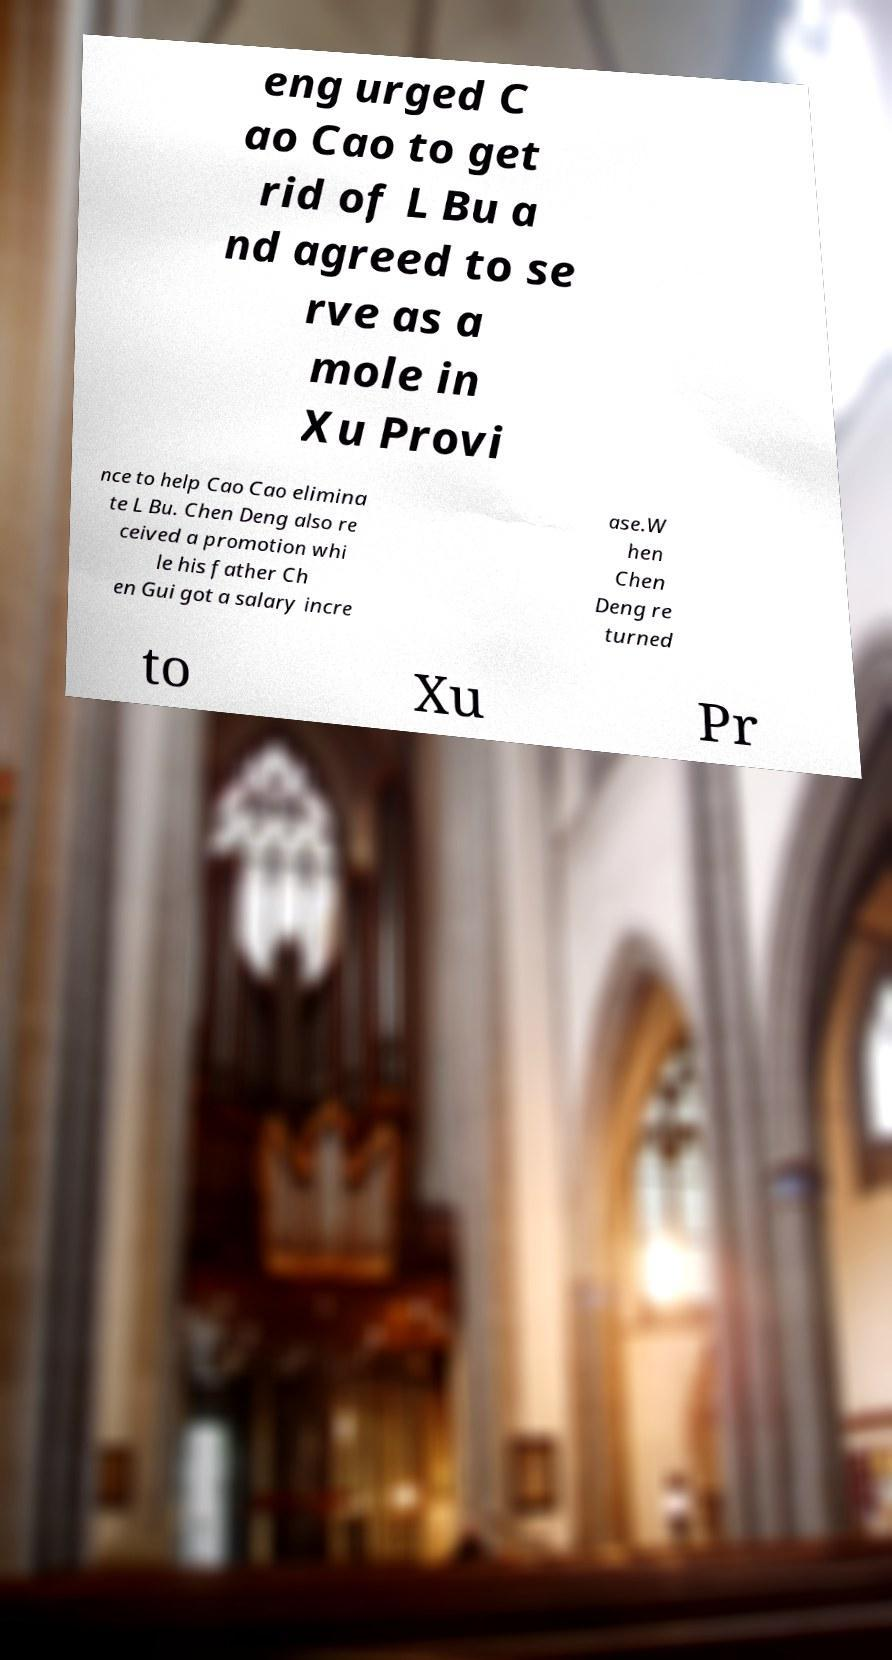There's text embedded in this image that I need extracted. Can you transcribe it verbatim? eng urged C ao Cao to get rid of L Bu a nd agreed to se rve as a mole in Xu Provi nce to help Cao Cao elimina te L Bu. Chen Deng also re ceived a promotion whi le his father Ch en Gui got a salary incre ase.W hen Chen Deng re turned to Xu Pr 